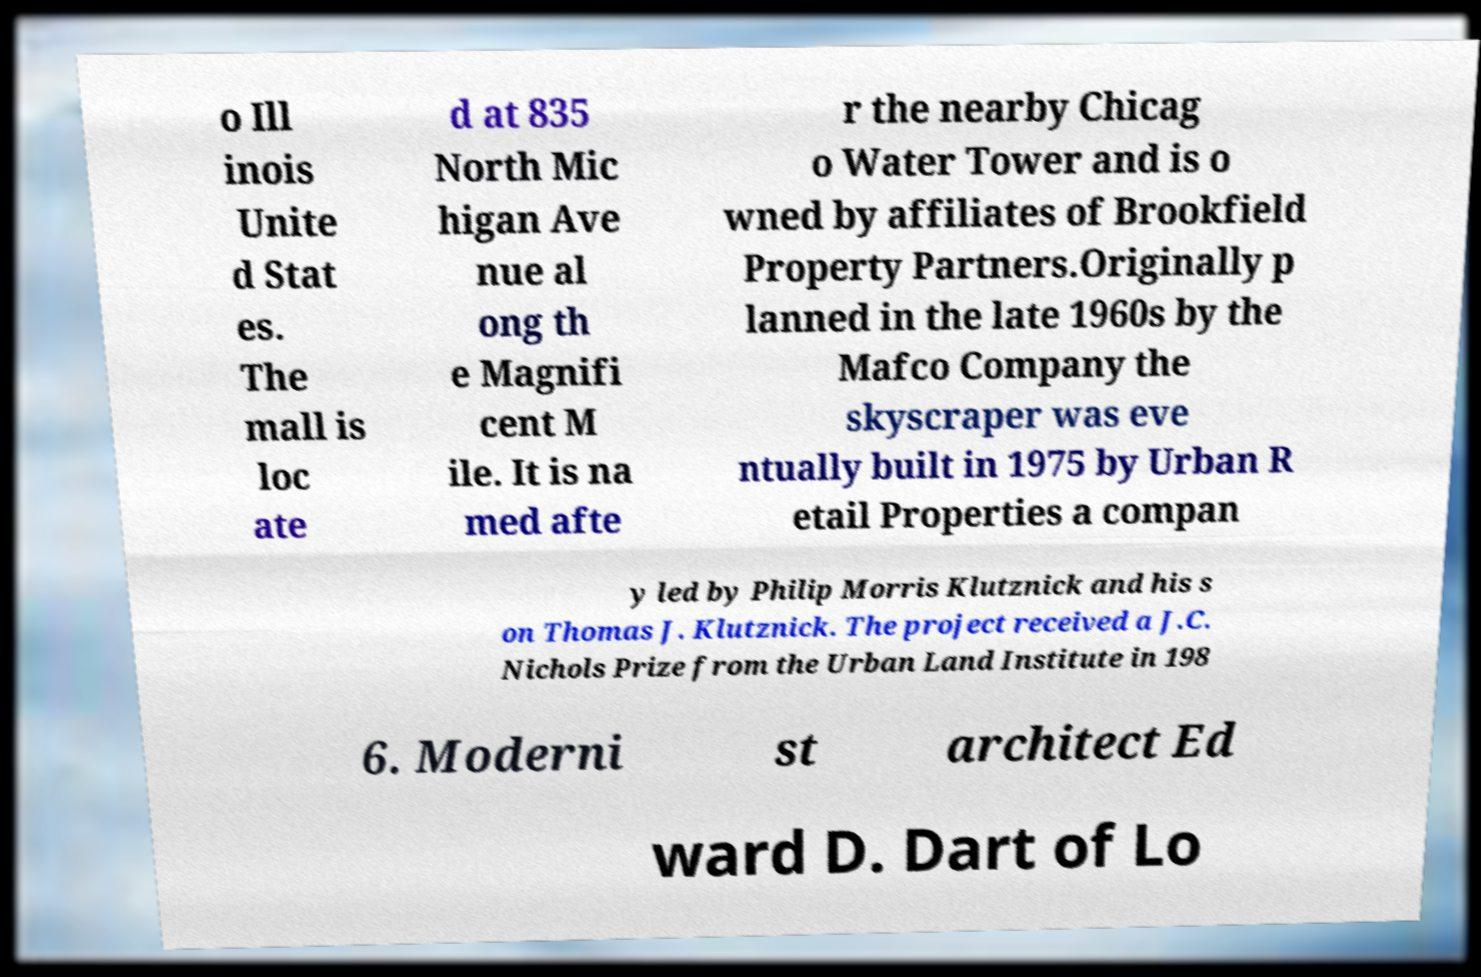Could you assist in decoding the text presented in this image and type it out clearly? o Ill inois Unite d Stat es. The mall is loc ate d at 835 North Mic higan Ave nue al ong th e Magnifi cent M ile. It is na med afte r the nearby Chicag o Water Tower and is o wned by affiliates of Brookfield Property Partners.Originally p lanned in the late 1960s by the Mafco Company the skyscraper was eve ntually built in 1975 by Urban R etail Properties a compan y led by Philip Morris Klutznick and his s on Thomas J. Klutznick. The project received a J.C. Nichols Prize from the Urban Land Institute in 198 6. Moderni st architect Ed ward D. Dart of Lo 